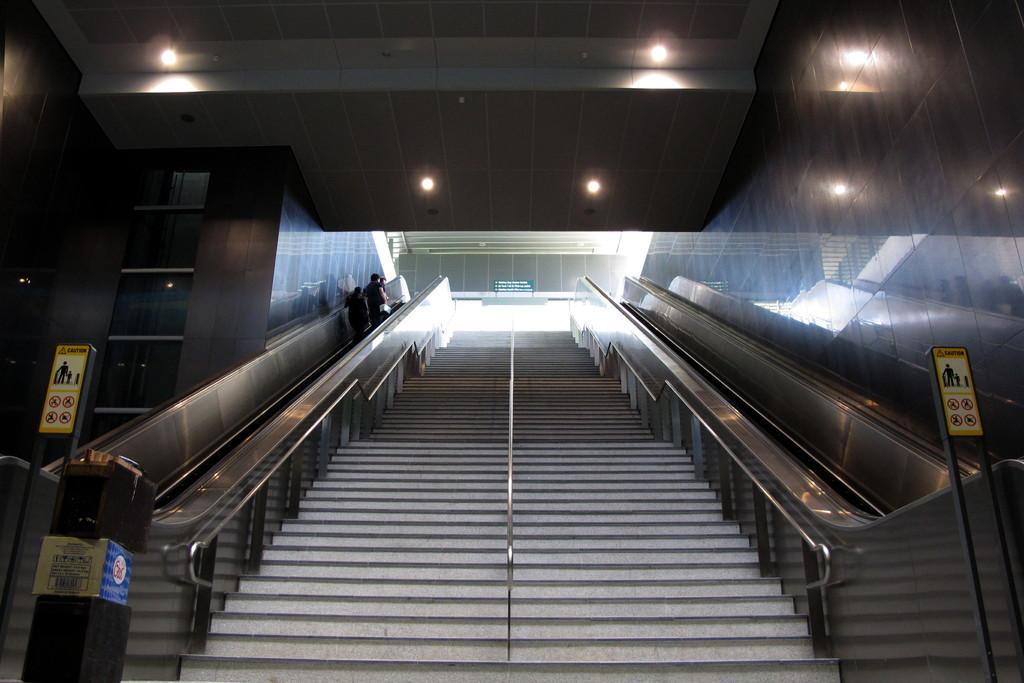How would you summarize this image in a sentence or two? In this image I can see stairs in the centre and in the front I can see few boards on the both side of this image. I can see something is written on these boards. In the background I can see few lights and few people. 